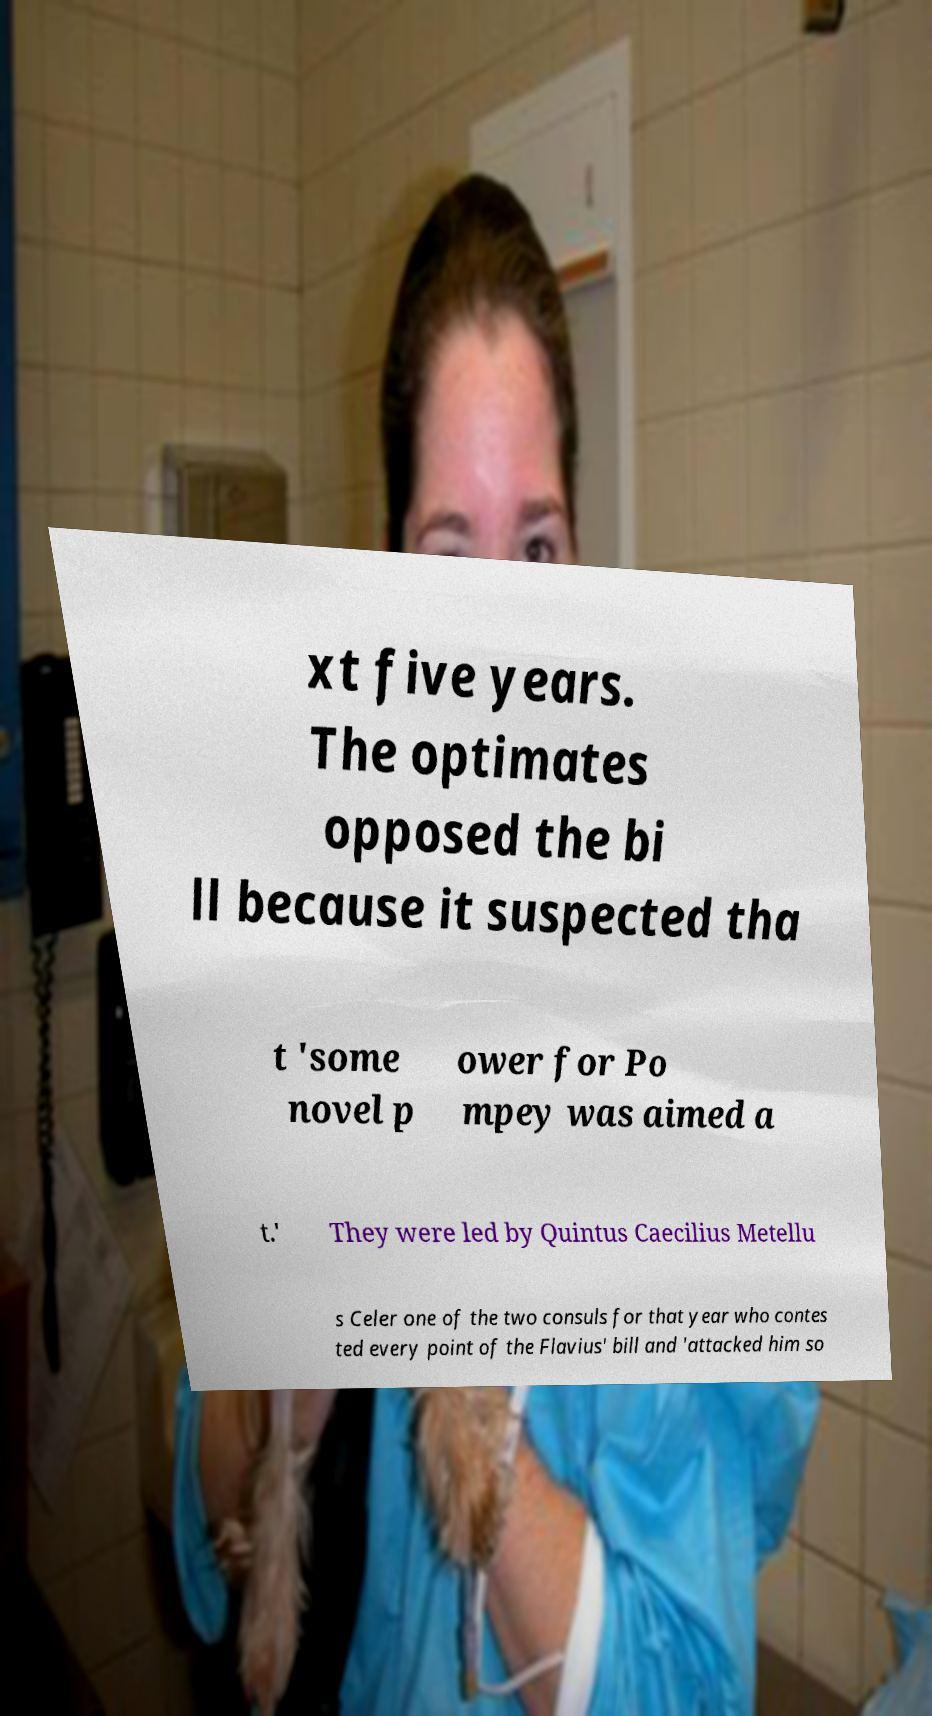Please read and relay the text visible in this image. What does it say? xt five years. The optimates opposed the bi ll because it suspected tha t 'some novel p ower for Po mpey was aimed a t.' They were led by Quintus Caecilius Metellu s Celer one of the two consuls for that year who contes ted every point of the Flavius' bill and 'attacked him so 